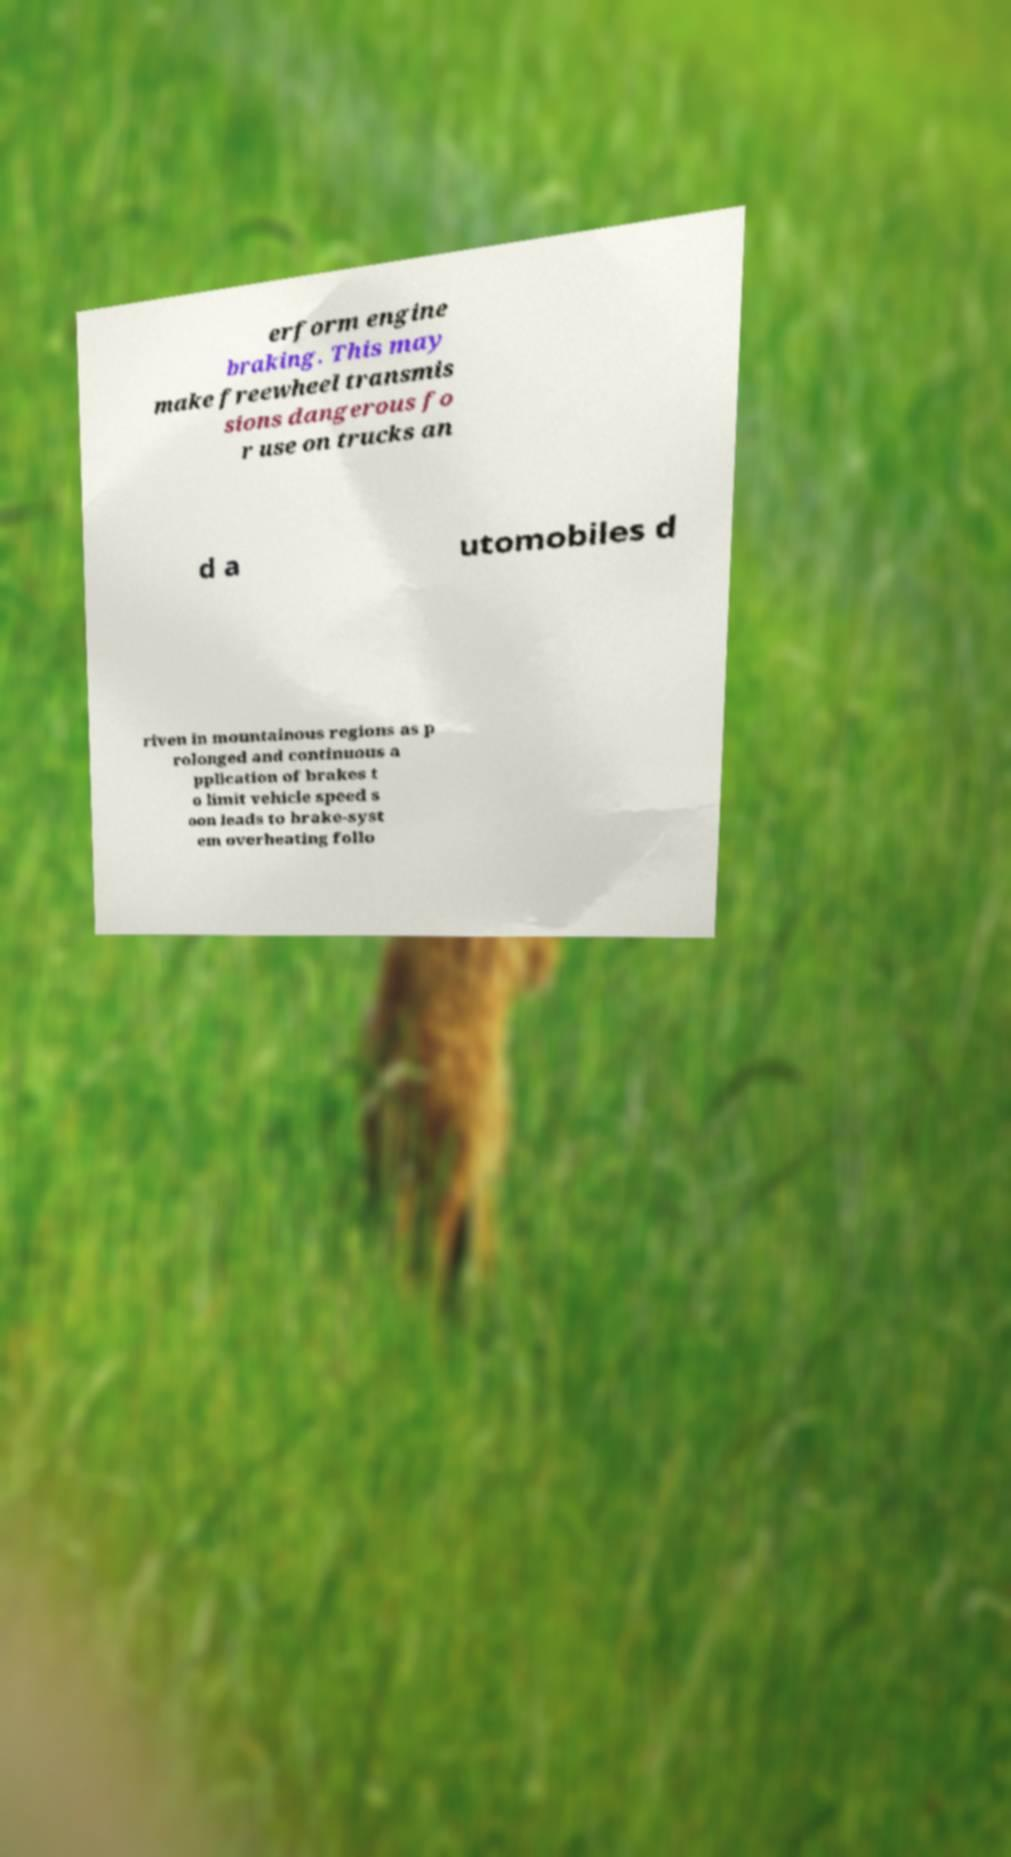Can you read and provide the text displayed in the image?This photo seems to have some interesting text. Can you extract and type it out for me? erform engine braking. This may make freewheel transmis sions dangerous fo r use on trucks an d a utomobiles d riven in mountainous regions as p rolonged and continuous a pplication of brakes t o limit vehicle speed s oon leads to brake-syst em overheating follo 